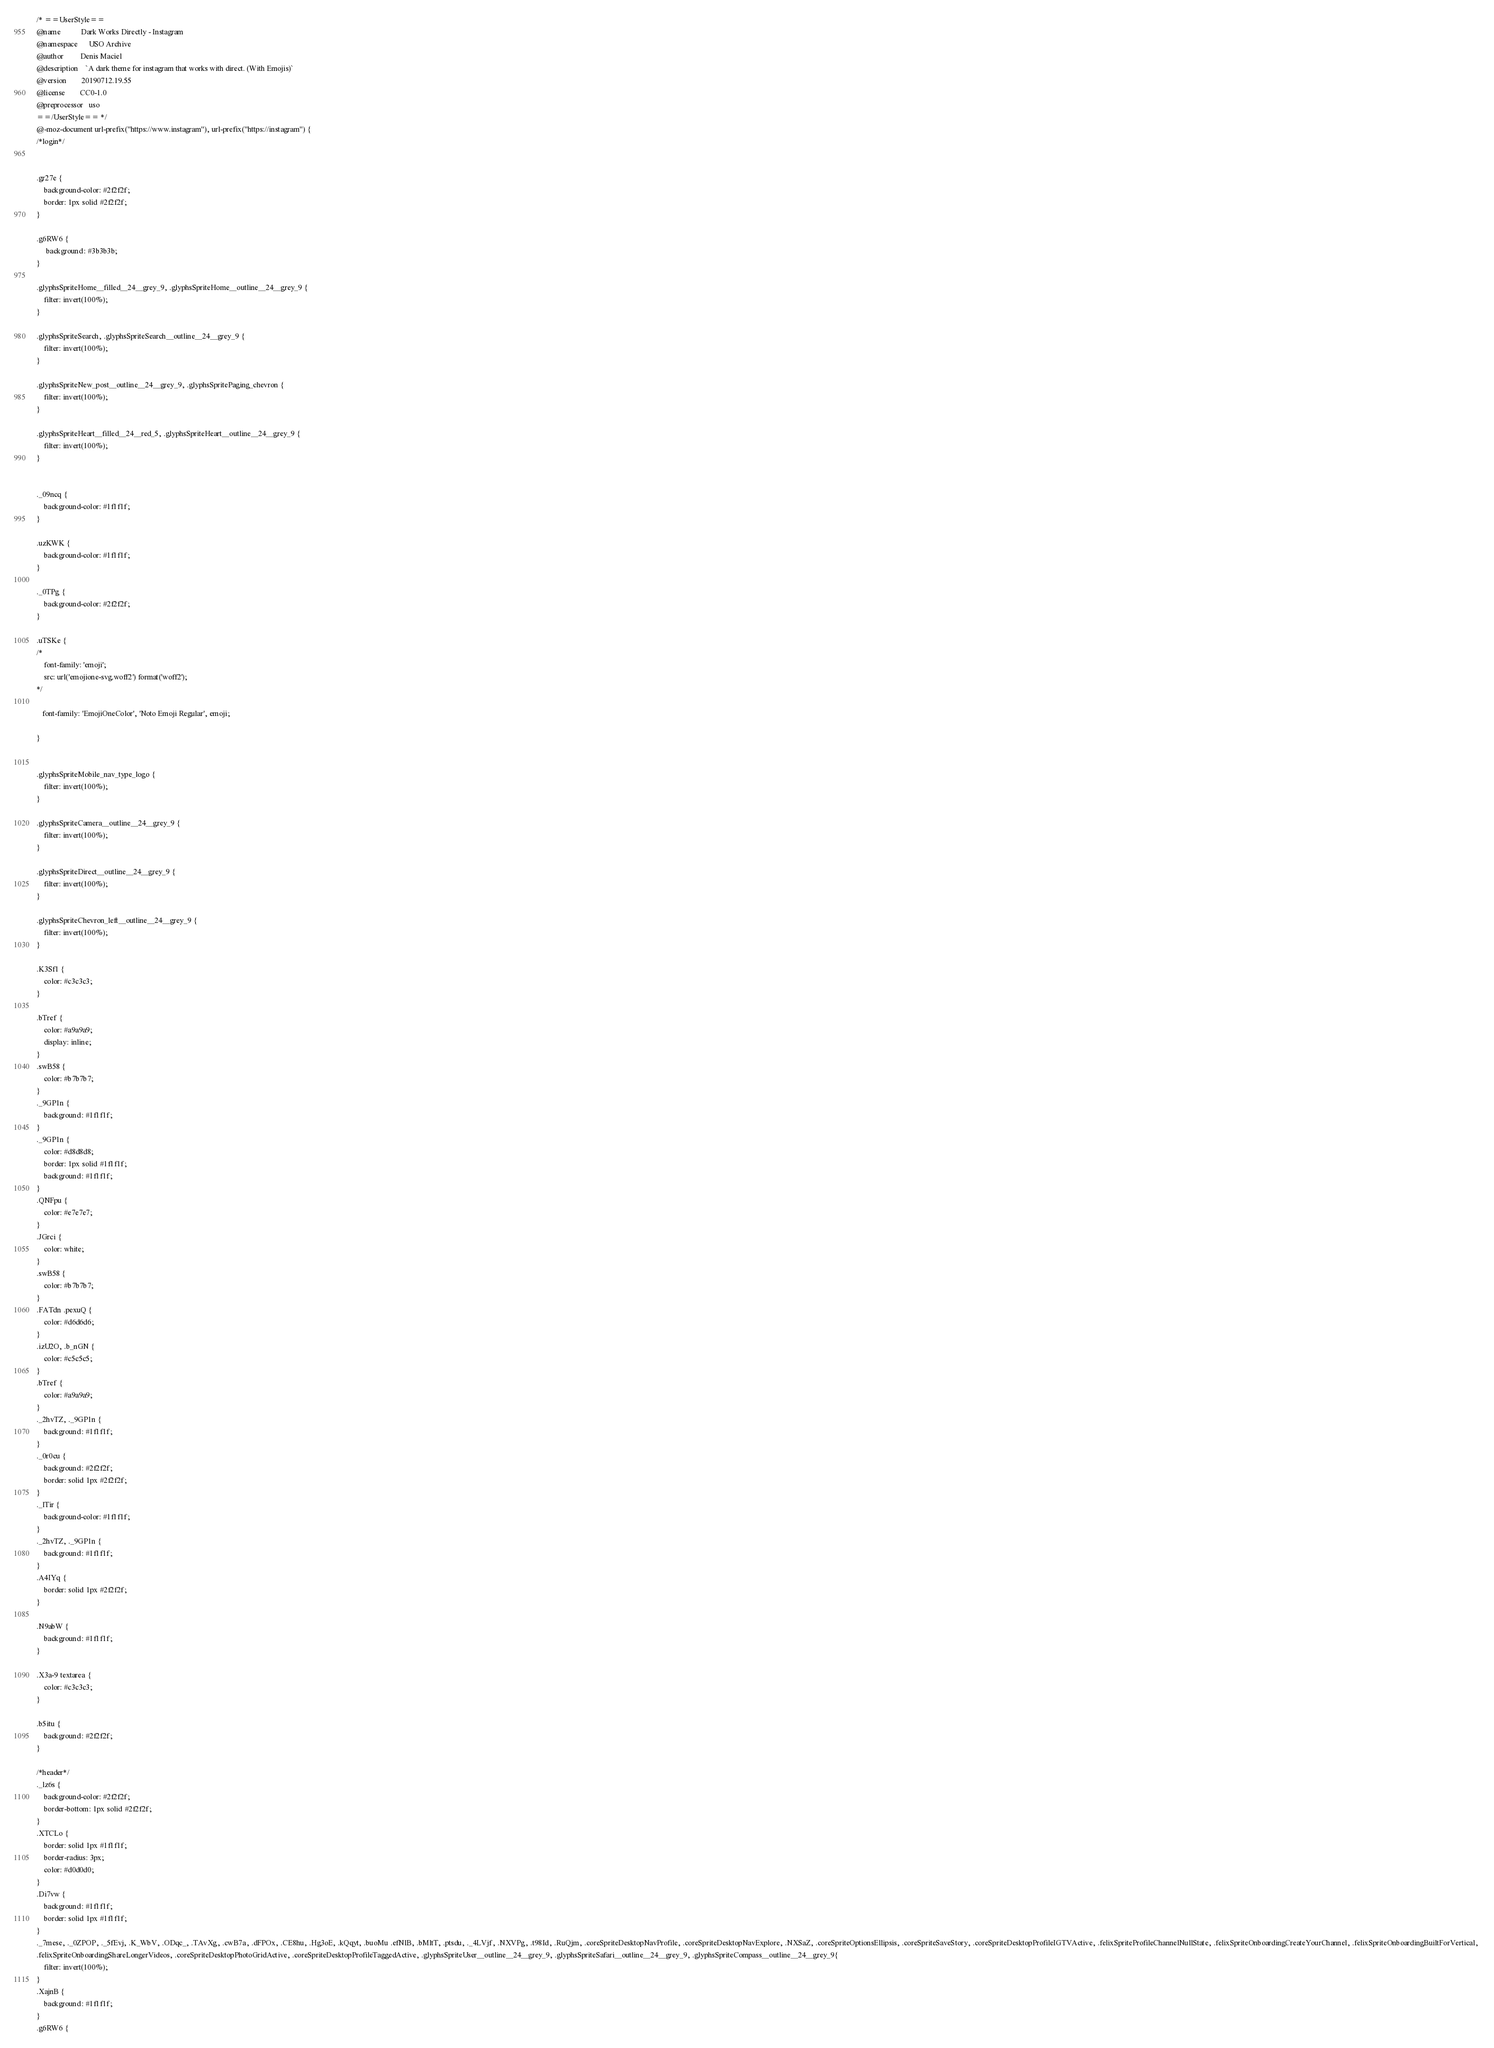Convert code to text. <code><loc_0><loc_0><loc_500><loc_500><_CSS_>/* ==UserStyle==
@name           Dark Works Directly - Instagram
@namespace      USO Archive
@author         Denis Maciel
@description    `A dark theme for instagram that works with direct. (With Emojis)`
@version        20190712.19.55
@license        CC0-1.0
@preprocessor   uso
==/UserStyle== */
@-moz-document url-prefix("https://www.instagram"), url-prefix("https://instagram") {
/*login*/


.gr27e {
    background-color: #2f2f2f;
    border: 1px solid #2f2f2f;
}

.g6RW6 {
     background: #3b3b3b;
}

.glyphsSpriteHome__filled__24__grey_9, .glyphsSpriteHome__outline__24__grey_9 {
	filter: invert(100%);
}

.glyphsSpriteSearch, .glyphsSpriteSearch__outline__24__grey_9 {
	filter: invert(100%);
}

.glyphsSpriteNew_post__outline__24__grey_9, .glyphsSpritePaging_chevron {
	filter: invert(100%);
}

.glyphsSpriteHeart__filled__24__red_5, .glyphsSpriteHeart__outline__24__grey_9 {
	filter: invert(100%);
}


._09ncq {
    background-color: #1f1f1f; 
} 

.uzKWK {
    background-color: #1f1f1f; 
}

._0TPg {
    background-color: #2f2f2f; 
}

.uTSKe {
/*
    font-family: 'emoji';
    src: url('emojione-svg.woff2') format('woff2');
*/
    
   font-family: 'EmojiOneColor', 'Noto Emoji Regular', emoji;

}


.glyphsSpriteMobile_nav_type_logo {
    filter: invert(100%);
}

.glyphsSpriteCamera__outline__24__grey_9 {
    filter: invert(100%);
}

.glyphsSpriteDirect__outline__24__grey_9 {
    filter: invert(100%);
}

.glyphsSpriteChevron_left__outline__24__grey_9 {
    filter: invert(100%);
}

.K3Sf1 {
    color: #c3c3c3;
}

.bTref {
    color: #a9a9a9;
    display: inline;
}
.swB58 {
    color: #b7b7b7;
}
._9GP1n {
    background: #1f1f1f;
}
._9GP1n {
    color: #d8d8d8;
    border: 1px solid #1f1f1f;
    background: #1f1f1f;
}
.QNFpu {
    color: #e7e7e7;
}
.JGrci {
    color: white;
}
.swB58 {
    color: #b7b7b7;
}
.FATdn .pexuQ {
    color: #d6d6d6;
}
.izU2O, .b_nGN {
    color: #c5c5c5;
}
.bTref {
    color: #a9a9a9;
}
._2hvTZ, ._9GP1n {
    background: #1f1f1f;
}
._0r0cu {
    background: #2f2f2f;
    border: solid 1px #2f2f2f;
}
._lTir {
    background-color: #1f1f1f;
}
._2hvTZ, ._9GP1n {
    background: #1f1f1f;
}
.A4IYq {
    border: solid 1px #2f2f2f;
}

.N9abW {
    background: #1f1f1f;
}

.X3a-9 textarea {
    color: #c3c3c3;
}

.b5itu {
    background: #2f2f2f;
}

/*header*/
._lz6s {
    background-color: #2f2f2f;
    border-bottom: 1px solid #2f2f2f;
}
.XTCLo {
    border: solid 1px #1f1f1f;
    border-radius: 3px;
    color: #d0d0d0;
}
.Di7vw {
    background: #1f1f1f;
    border: solid 1px #1f1f1f;
}
._7mese, ._0ZPOP, ._5fEvj, .K_WbV, .ODqc_, .TAvXg, .cwB7a, .dFPOx, .CE8hu, .Hg3oE, .kQqyt, .buoMu .efNlB, .bMltT, .ptsdu, ._4LVjf, .NXVPg, .t98Id, .RuQjm, .coreSpriteDesktopNavProfile, .coreSpriteDesktopNavExplore, .NXSaZ, .coreSpriteOptionsEllipsis, .coreSpriteSaveStory, .coreSpriteDesktopProfileIGTVActive, .felixSpriteProfileChannelNullState, .felixSpriteOnboardingCreateYourChannel, .felixSpriteOnboardingBuiltForVertical, 
.felixSpriteOnboardingShareLongerVideos, .coreSpriteDesktopPhotoGridActive, .coreSpriteDesktopProfileTaggedActive, .glyphsSpriteUser__outline__24__grey_9, .glyphsSpriteSafari__outline__24__grey_9, .glyphsSpriteCompass__outline__24__grey_9{
    filter: invert(100%);
}
.XajnB {
    background: #1f1f1f;
}
.g6RW6 {</code> 